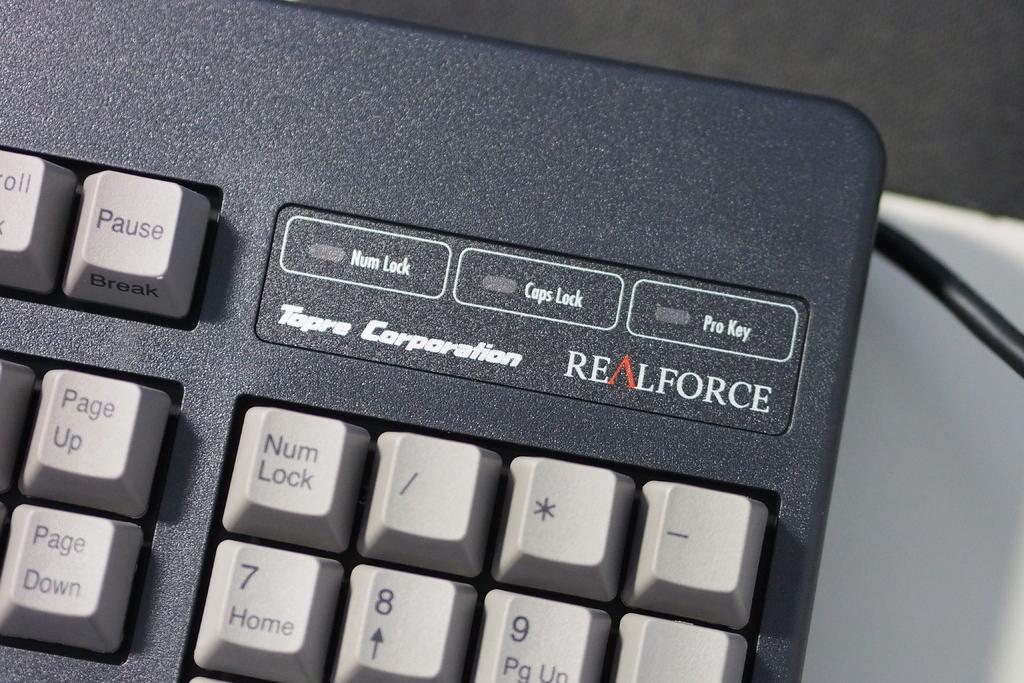Can you describe this image briefly? In this image there is a keyboard, on that keyboard there is some text written. 